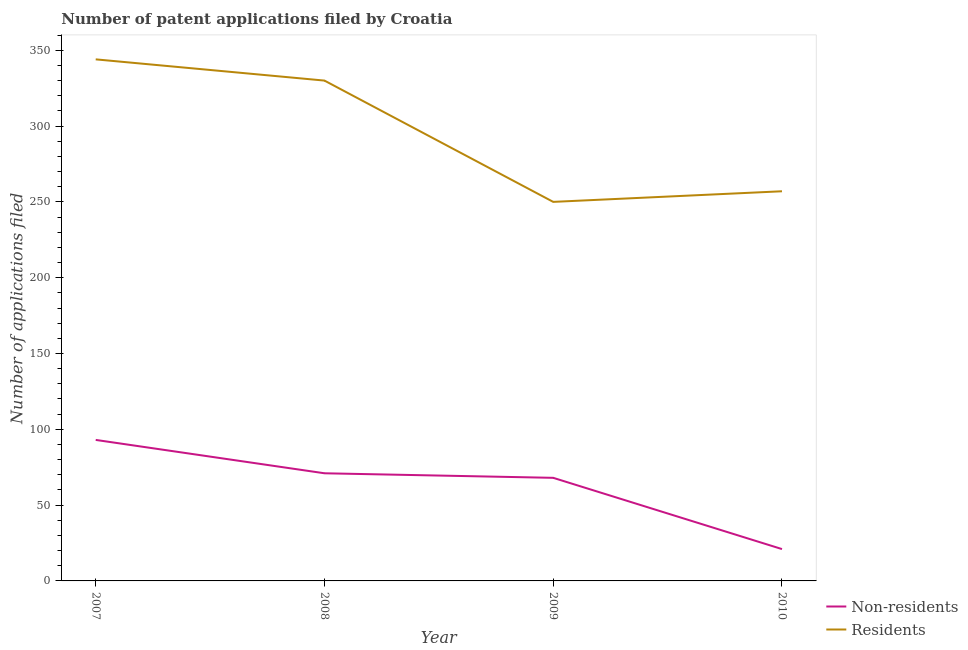Does the line corresponding to number of patent applications by non residents intersect with the line corresponding to number of patent applications by residents?
Provide a short and direct response. No. What is the number of patent applications by non residents in 2008?
Offer a terse response. 71. Across all years, what is the maximum number of patent applications by residents?
Your response must be concise. 344. Across all years, what is the minimum number of patent applications by non residents?
Ensure brevity in your answer.  21. In which year was the number of patent applications by non residents minimum?
Offer a terse response. 2010. What is the total number of patent applications by non residents in the graph?
Offer a terse response. 253. What is the difference between the number of patent applications by residents in 2007 and that in 2009?
Give a very brief answer. 94. What is the difference between the number of patent applications by residents in 2008 and the number of patent applications by non residents in 2007?
Offer a very short reply. 237. What is the average number of patent applications by residents per year?
Give a very brief answer. 295.25. In the year 2007, what is the difference between the number of patent applications by non residents and number of patent applications by residents?
Your answer should be compact. -251. What is the ratio of the number of patent applications by non residents in 2007 to that in 2009?
Provide a succinct answer. 1.37. Is the number of patent applications by residents in 2009 less than that in 2010?
Keep it short and to the point. Yes. What is the difference between the highest and the second highest number of patent applications by residents?
Ensure brevity in your answer.  14. What is the difference between the highest and the lowest number of patent applications by non residents?
Provide a short and direct response. 72. In how many years, is the number of patent applications by non residents greater than the average number of patent applications by non residents taken over all years?
Offer a very short reply. 3. Is the number of patent applications by non residents strictly greater than the number of patent applications by residents over the years?
Provide a short and direct response. No. Is the number of patent applications by residents strictly less than the number of patent applications by non residents over the years?
Keep it short and to the point. No. How many years are there in the graph?
Your answer should be compact. 4. Are the values on the major ticks of Y-axis written in scientific E-notation?
Provide a succinct answer. No. Does the graph contain any zero values?
Keep it short and to the point. No. How are the legend labels stacked?
Your response must be concise. Vertical. What is the title of the graph?
Offer a terse response. Number of patent applications filed by Croatia. Does "Birth rate" appear as one of the legend labels in the graph?
Offer a terse response. No. What is the label or title of the Y-axis?
Offer a terse response. Number of applications filed. What is the Number of applications filed in Non-residents in 2007?
Make the answer very short. 93. What is the Number of applications filed of Residents in 2007?
Offer a terse response. 344. What is the Number of applications filed in Non-residents in 2008?
Ensure brevity in your answer.  71. What is the Number of applications filed of Residents in 2008?
Ensure brevity in your answer.  330. What is the Number of applications filed of Non-residents in 2009?
Provide a short and direct response. 68. What is the Number of applications filed of Residents in 2009?
Your answer should be compact. 250. What is the Number of applications filed in Residents in 2010?
Your response must be concise. 257. Across all years, what is the maximum Number of applications filed of Non-residents?
Keep it short and to the point. 93. Across all years, what is the maximum Number of applications filed in Residents?
Ensure brevity in your answer.  344. Across all years, what is the minimum Number of applications filed of Residents?
Ensure brevity in your answer.  250. What is the total Number of applications filed in Non-residents in the graph?
Your answer should be compact. 253. What is the total Number of applications filed of Residents in the graph?
Ensure brevity in your answer.  1181. What is the difference between the Number of applications filed of Non-residents in 2007 and that in 2008?
Provide a succinct answer. 22. What is the difference between the Number of applications filed of Residents in 2007 and that in 2008?
Your response must be concise. 14. What is the difference between the Number of applications filed of Non-residents in 2007 and that in 2009?
Give a very brief answer. 25. What is the difference between the Number of applications filed of Residents in 2007 and that in 2009?
Give a very brief answer. 94. What is the difference between the Number of applications filed in Non-residents in 2007 and that in 2010?
Your answer should be very brief. 72. What is the difference between the Number of applications filed of Residents in 2008 and that in 2009?
Provide a succinct answer. 80. What is the difference between the Number of applications filed of Residents in 2009 and that in 2010?
Provide a short and direct response. -7. What is the difference between the Number of applications filed in Non-residents in 2007 and the Number of applications filed in Residents in 2008?
Give a very brief answer. -237. What is the difference between the Number of applications filed of Non-residents in 2007 and the Number of applications filed of Residents in 2009?
Your answer should be very brief. -157. What is the difference between the Number of applications filed of Non-residents in 2007 and the Number of applications filed of Residents in 2010?
Provide a succinct answer. -164. What is the difference between the Number of applications filed in Non-residents in 2008 and the Number of applications filed in Residents in 2009?
Your answer should be very brief. -179. What is the difference between the Number of applications filed of Non-residents in 2008 and the Number of applications filed of Residents in 2010?
Provide a short and direct response. -186. What is the difference between the Number of applications filed of Non-residents in 2009 and the Number of applications filed of Residents in 2010?
Offer a terse response. -189. What is the average Number of applications filed in Non-residents per year?
Your answer should be very brief. 63.25. What is the average Number of applications filed of Residents per year?
Keep it short and to the point. 295.25. In the year 2007, what is the difference between the Number of applications filed in Non-residents and Number of applications filed in Residents?
Offer a terse response. -251. In the year 2008, what is the difference between the Number of applications filed of Non-residents and Number of applications filed of Residents?
Give a very brief answer. -259. In the year 2009, what is the difference between the Number of applications filed in Non-residents and Number of applications filed in Residents?
Provide a short and direct response. -182. In the year 2010, what is the difference between the Number of applications filed in Non-residents and Number of applications filed in Residents?
Offer a very short reply. -236. What is the ratio of the Number of applications filed of Non-residents in 2007 to that in 2008?
Offer a very short reply. 1.31. What is the ratio of the Number of applications filed of Residents in 2007 to that in 2008?
Your response must be concise. 1.04. What is the ratio of the Number of applications filed of Non-residents in 2007 to that in 2009?
Keep it short and to the point. 1.37. What is the ratio of the Number of applications filed of Residents in 2007 to that in 2009?
Offer a terse response. 1.38. What is the ratio of the Number of applications filed of Non-residents in 2007 to that in 2010?
Your response must be concise. 4.43. What is the ratio of the Number of applications filed of Residents in 2007 to that in 2010?
Give a very brief answer. 1.34. What is the ratio of the Number of applications filed in Non-residents in 2008 to that in 2009?
Your response must be concise. 1.04. What is the ratio of the Number of applications filed of Residents in 2008 to that in 2009?
Offer a very short reply. 1.32. What is the ratio of the Number of applications filed in Non-residents in 2008 to that in 2010?
Ensure brevity in your answer.  3.38. What is the ratio of the Number of applications filed of Residents in 2008 to that in 2010?
Make the answer very short. 1.28. What is the ratio of the Number of applications filed in Non-residents in 2009 to that in 2010?
Give a very brief answer. 3.24. What is the ratio of the Number of applications filed in Residents in 2009 to that in 2010?
Give a very brief answer. 0.97. What is the difference between the highest and the lowest Number of applications filed of Non-residents?
Keep it short and to the point. 72. What is the difference between the highest and the lowest Number of applications filed of Residents?
Keep it short and to the point. 94. 